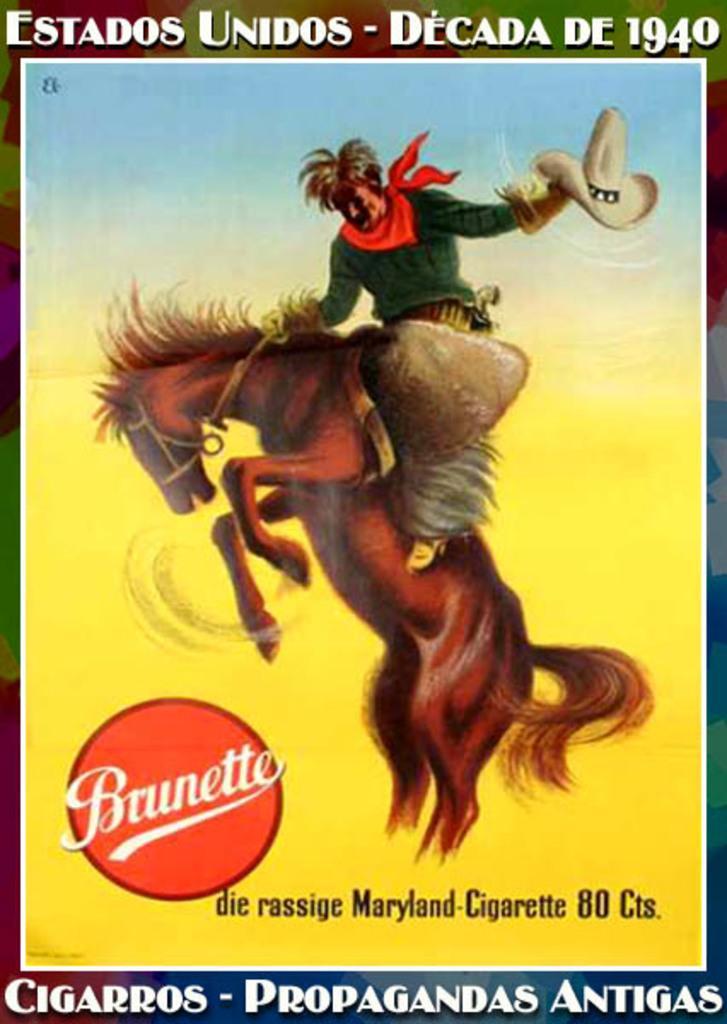Describe this image in one or two sentences. In this image there is a poster, in that poster there is a horse and there is a man. 